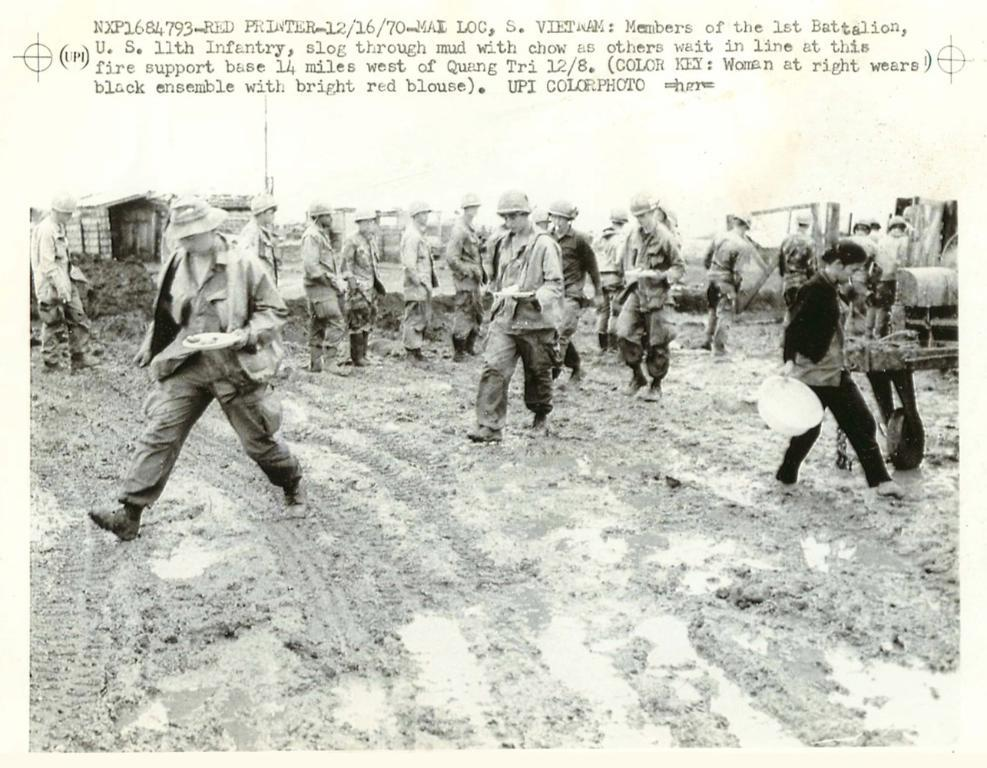What is in the foreground of the image? There is mud in the foreground of the image. What can be seen in the middle of the image? There are people, vehicles, and other objects in the middle of the image. What is visible at the top of the image? There is sky visible at the top of the image, and there is also text present. Are there any boats visible in the image? There are no boats present in the image. Did an earthquake occur in the image? There is no indication of an earthquake in the image. 